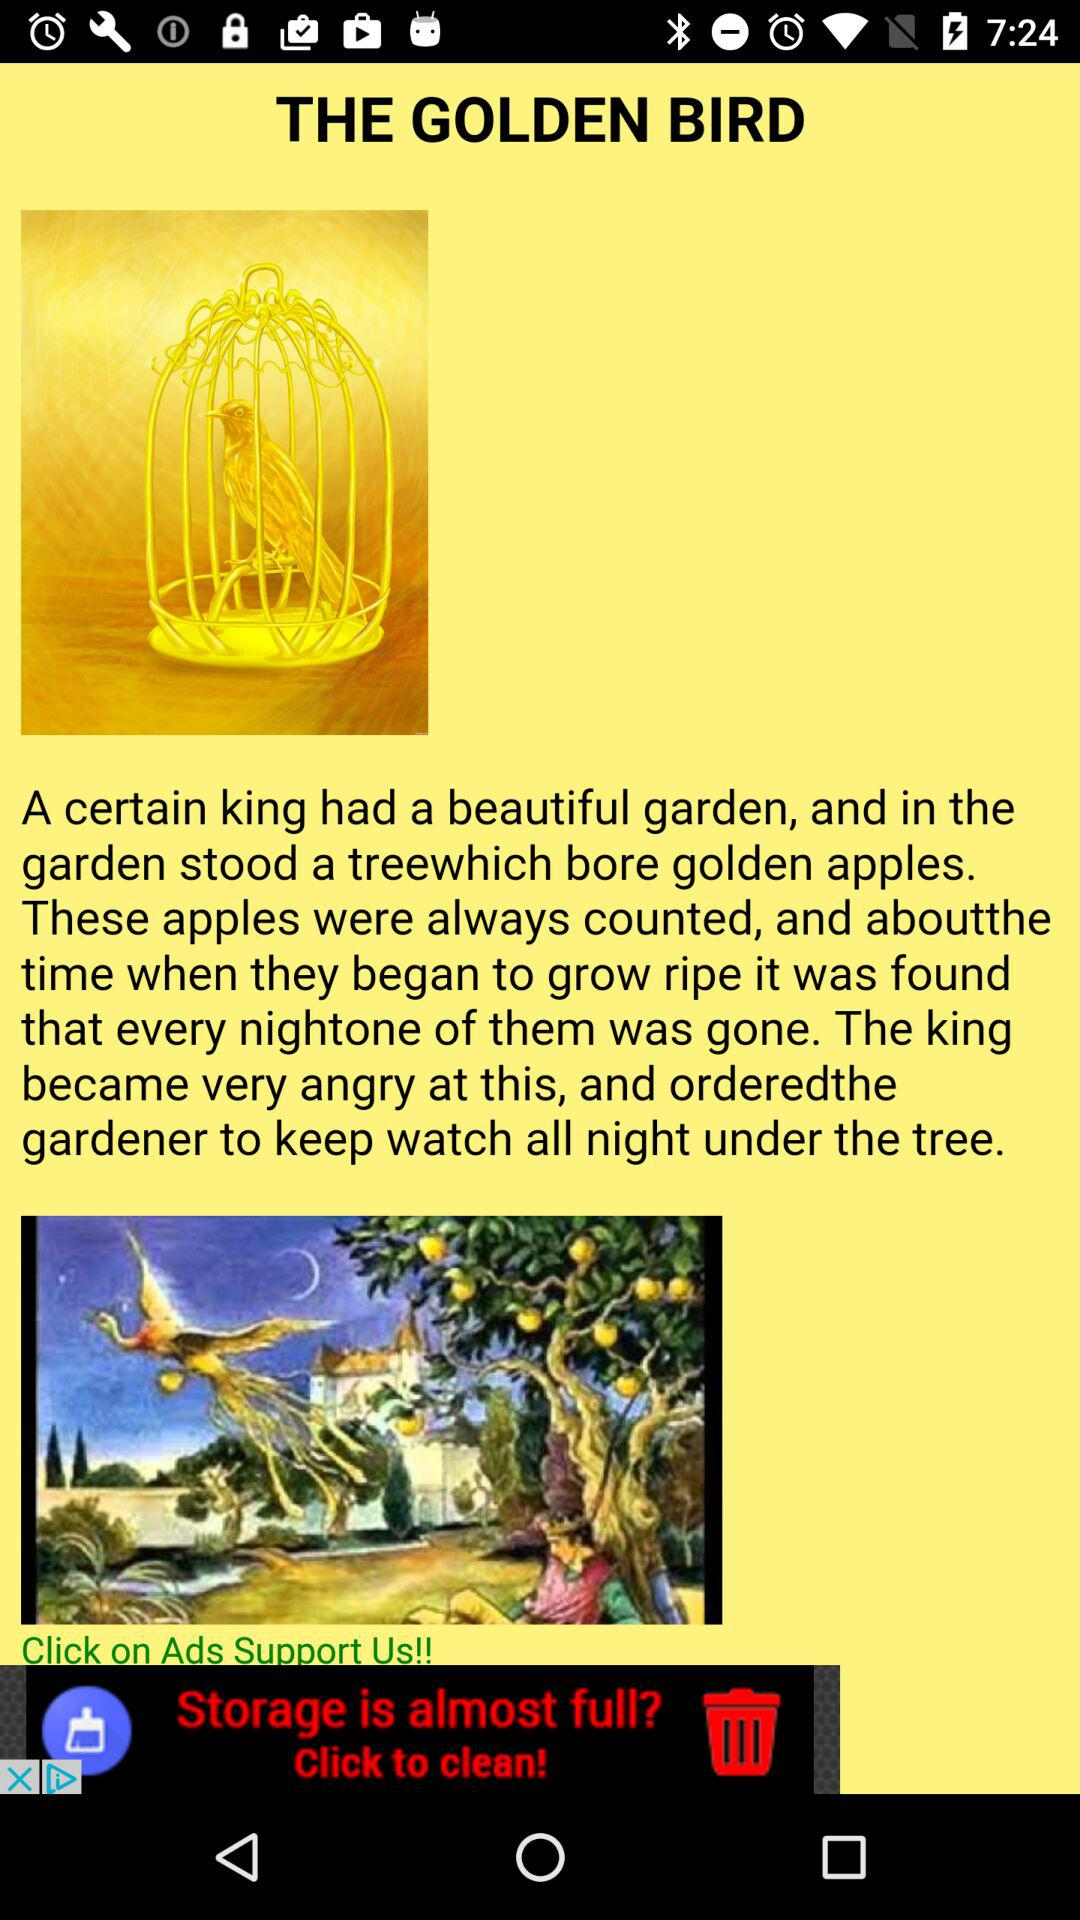What is the title? The title is "THE GOLDEN BIRD". 